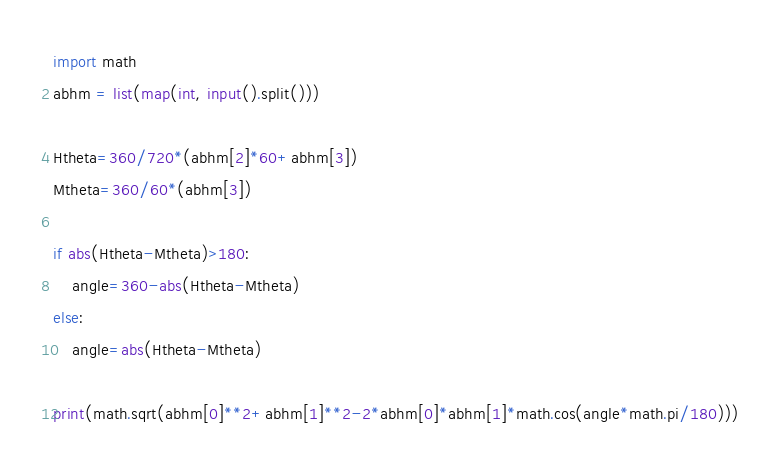<code> <loc_0><loc_0><loc_500><loc_500><_Python_>import math
abhm = list(map(int, input().split()))

Htheta=360/720*(abhm[2]*60+abhm[3])
Mtheta=360/60*(abhm[3])

if abs(Htheta-Mtheta)>180:
    angle=360-abs(Htheta-Mtheta)
else:
    angle=abs(Htheta-Mtheta)

print(math.sqrt(abhm[0]**2+abhm[1]**2-2*abhm[0]*abhm[1]*math.cos(angle*math.pi/180)))


</code> 